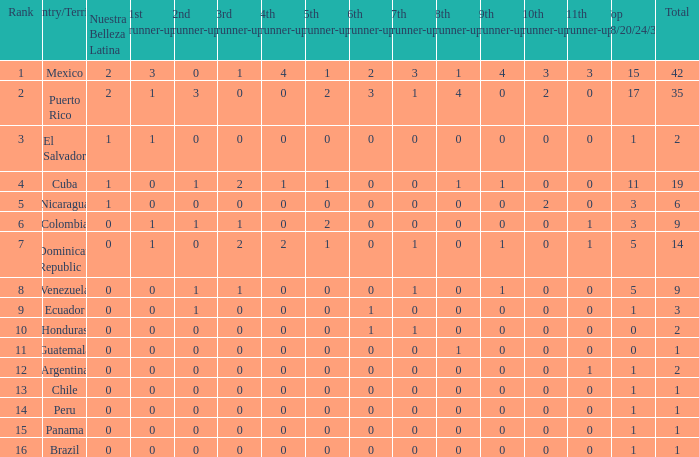What is the 7th runner-up of the country with a 10th runner-up greater than 0, a 9th runner-up greater than 0, and an 8th runner-up greater than 1? None. 